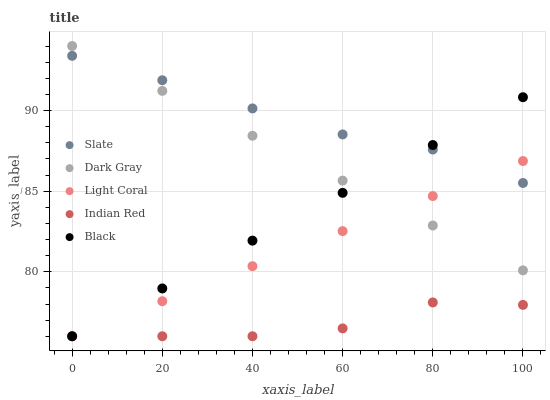Does Indian Red have the minimum area under the curve?
Answer yes or no. Yes. Does Slate have the maximum area under the curve?
Answer yes or no. Yes. Does Light Coral have the minimum area under the curve?
Answer yes or no. No. Does Light Coral have the maximum area under the curve?
Answer yes or no. No. Is Dark Gray the smoothest?
Answer yes or no. Yes. Is Indian Red the roughest?
Answer yes or no. Yes. Is Slate the smoothest?
Answer yes or no. No. Is Slate the roughest?
Answer yes or no. No. Does Light Coral have the lowest value?
Answer yes or no. Yes. Does Slate have the lowest value?
Answer yes or no. No. Does Dark Gray have the highest value?
Answer yes or no. Yes. Does Light Coral have the highest value?
Answer yes or no. No. Is Indian Red less than Dark Gray?
Answer yes or no. Yes. Is Slate greater than Indian Red?
Answer yes or no. Yes. Does Dark Gray intersect Light Coral?
Answer yes or no. Yes. Is Dark Gray less than Light Coral?
Answer yes or no. No. Is Dark Gray greater than Light Coral?
Answer yes or no. No. Does Indian Red intersect Dark Gray?
Answer yes or no. No. 